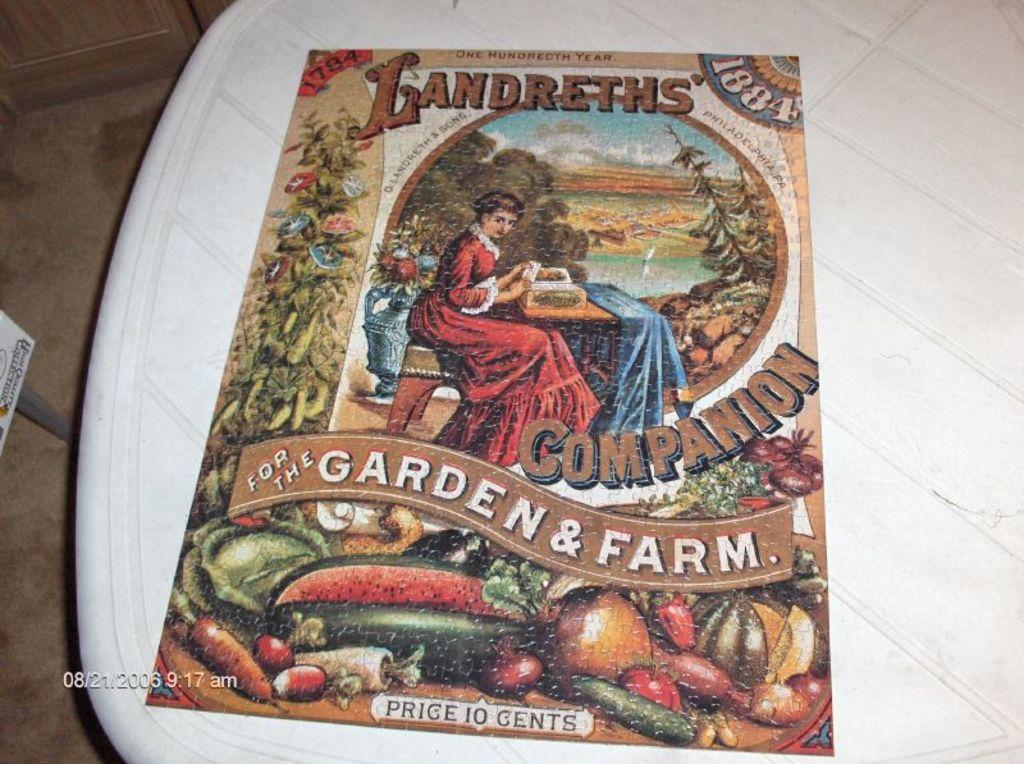<image>
Write a terse but informative summary of the picture. The front cover of an 1884 book about gardening that cost ten cents at the time of publication. 